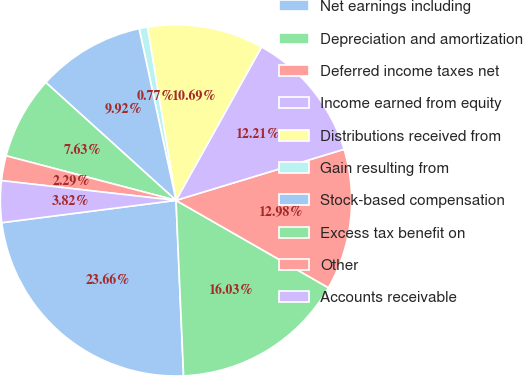Convert chart to OTSL. <chart><loc_0><loc_0><loc_500><loc_500><pie_chart><fcel>Net earnings including<fcel>Depreciation and amortization<fcel>Deferred income taxes net<fcel>Income earned from equity<fcel>Distributions received from<fcel>Gain resulting from<fcel>Stock-based compensation<fcel>Excess tax benefit on<fcel>Other<fcel>Accounts receivable<nl><fcel>23.66%<fcel>16.03%<fcel>12.98%<fcel>12.21%<fcel>10.69%<fcel>0.77%<fcel>9.92%<fcel>7.63%<fcel>2.29%<fcel>3.82%<nl></chart> 